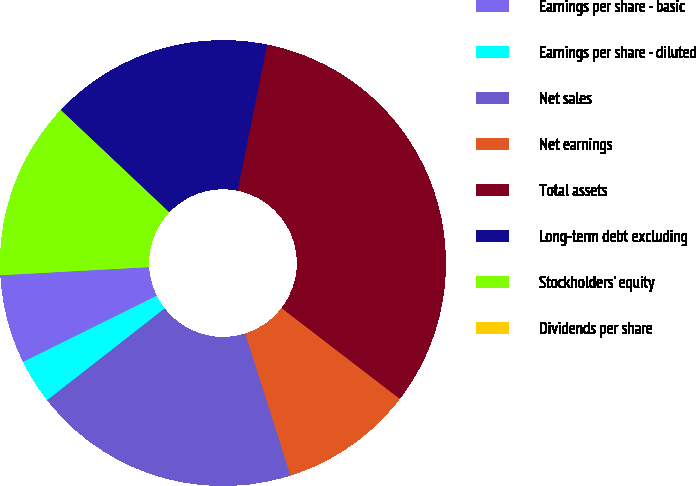Convert chart to OTSL. <chart><loc_0><loc_0><loc_500><loc_500><pie_chart><fcel>Earnings per share - basic<fcel>Earnings per share - diluted<fcel>Net sales<fcel>Net earnings<fcel>Total assets<fcel>Long-term debt excluding<fcel>Stockholders' equity<fcel>Dividends per share<nl><fcel>6.45%<fcel>3.23%<fcel>19.35%<fcel>9.68%<fcel>32.25%<fcel>16.13%<fcel>12.9%<fcel>0.0%<nl></chart> 